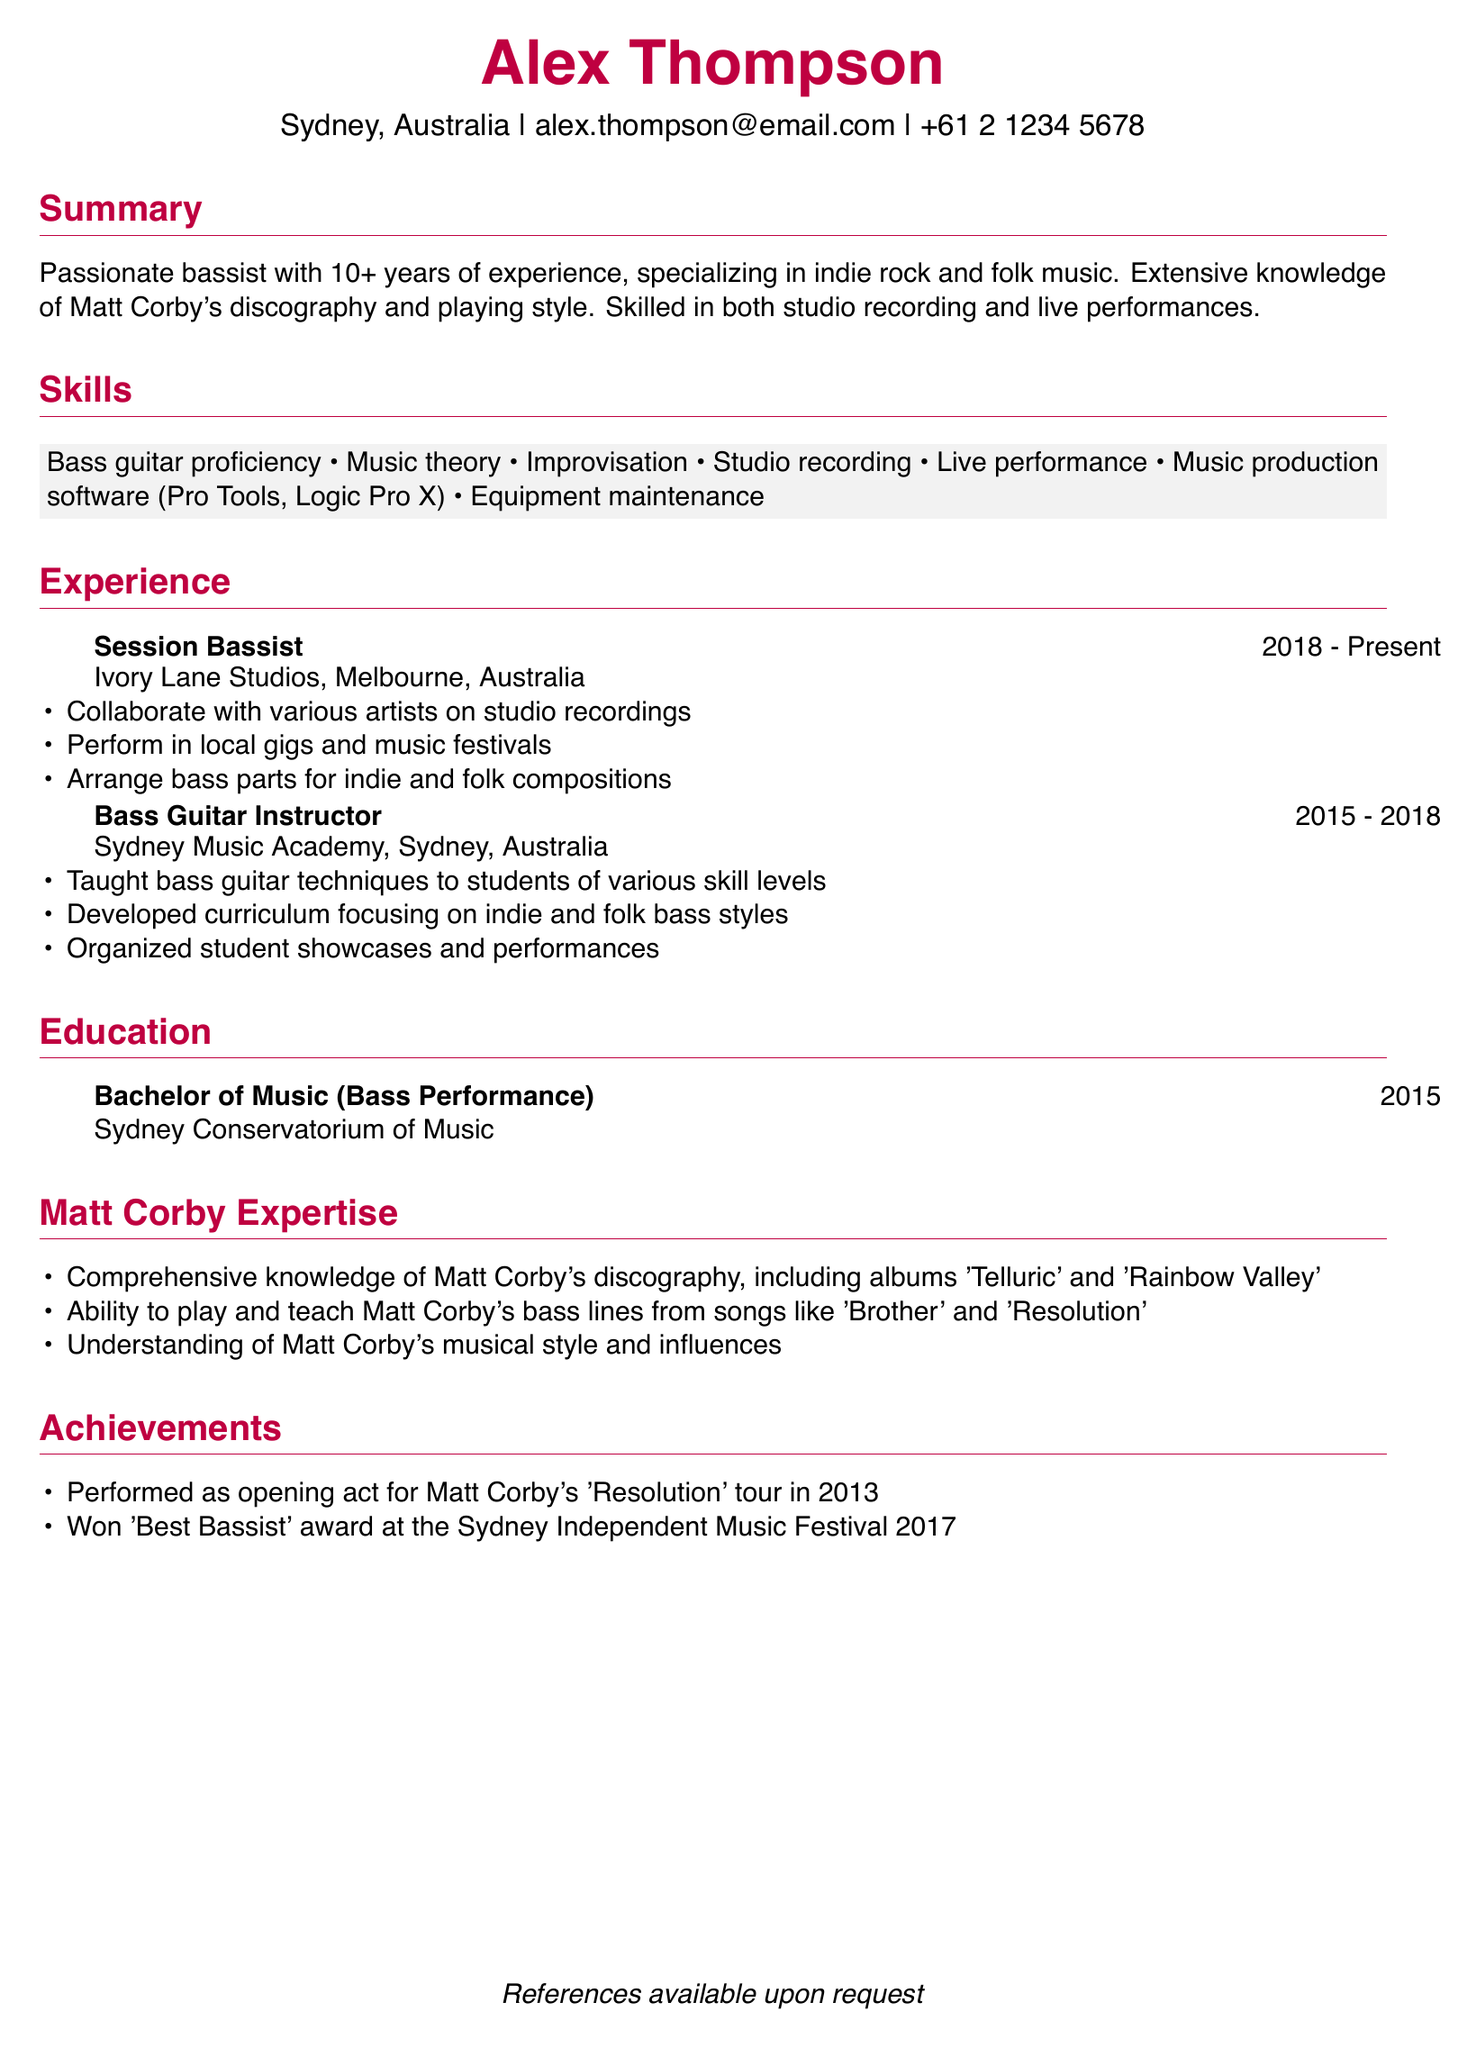what is the name of the person? The name of the person is provided in the personal information section of the document.
Answer: Alex Thompson where is the individual located? The person's location is mentioned in the personal information section.
Answer: Sydney, Australia what is the highest degree earned by Alex? The education section specifies the degree obtained and the institution.
Answer: Bachelor of Music (Bass Performance) which music software is mentioned under skills? The skills section lists various music production software that the individual is skilled in.
Answer: Pro Tools, Logic Pro X how many years of experience does Alex have? The summary section mentions the total duration of experience in music.
Answer: 10+ what type of music does Alex specialize in? The summary section highlights the specific genres the individual focuses on.
Answer: Indie rock and folk music which album is specifically mentioned in Matt Corby’s discography knowledge? The Matt Corby expertise section lists specific albums known by the individual.
Answer: Telluric what year did Alex graduate? The education section provides the graduation year for the degree obtained.
Answer: 2015 what award did Alex win at the Sydney Independent Music Festival? The achievements section details the recognition received by Alex in 2017.
Answer: Best Bassist 